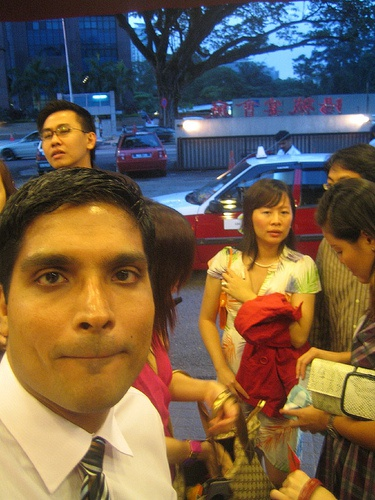Describe the objects in this image and their specific colors. I can see people in black, olive, tan, and orange tones, people in black, maroon, orange, and olive tones, people in black, olive, and maroon tones, people in black, maroon, brown, and gray tones, and car in black, maroon, blue, and brown tones in this image. 